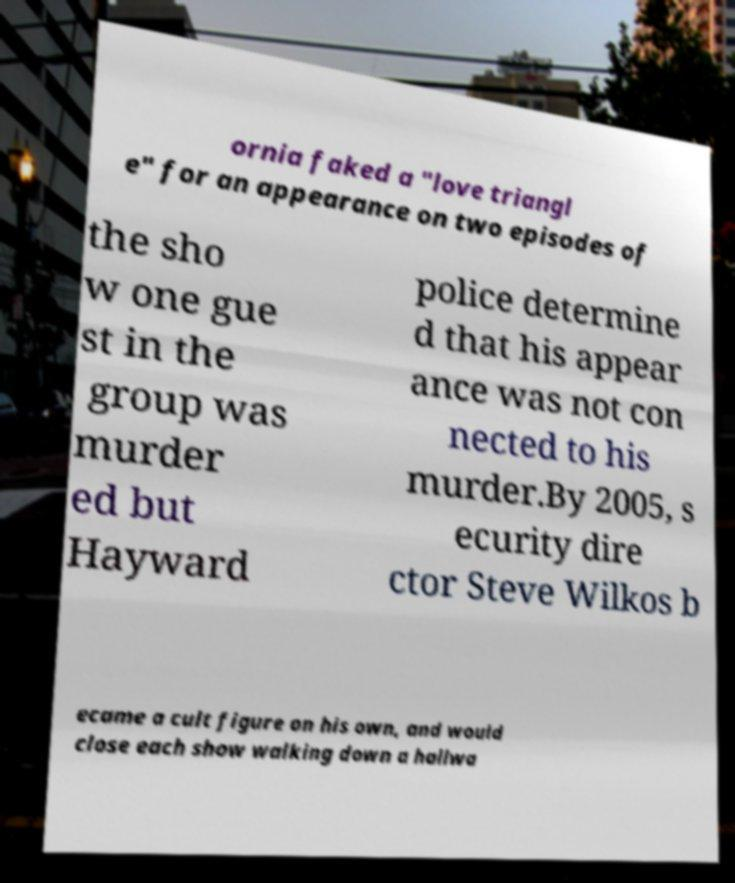Please read and relay the text visible in this image. What does it say? ornia faked a "love triangl e" for an appearance on two episodes of the sho w one gue st in the group was murder ed but Hayward police determine d that his appear ance was not con nected to his murder.By 2005, s ecurity dire ctor Steve Wilkos b ecame a cult figure on his own, and would close each show walking down a hallwa 